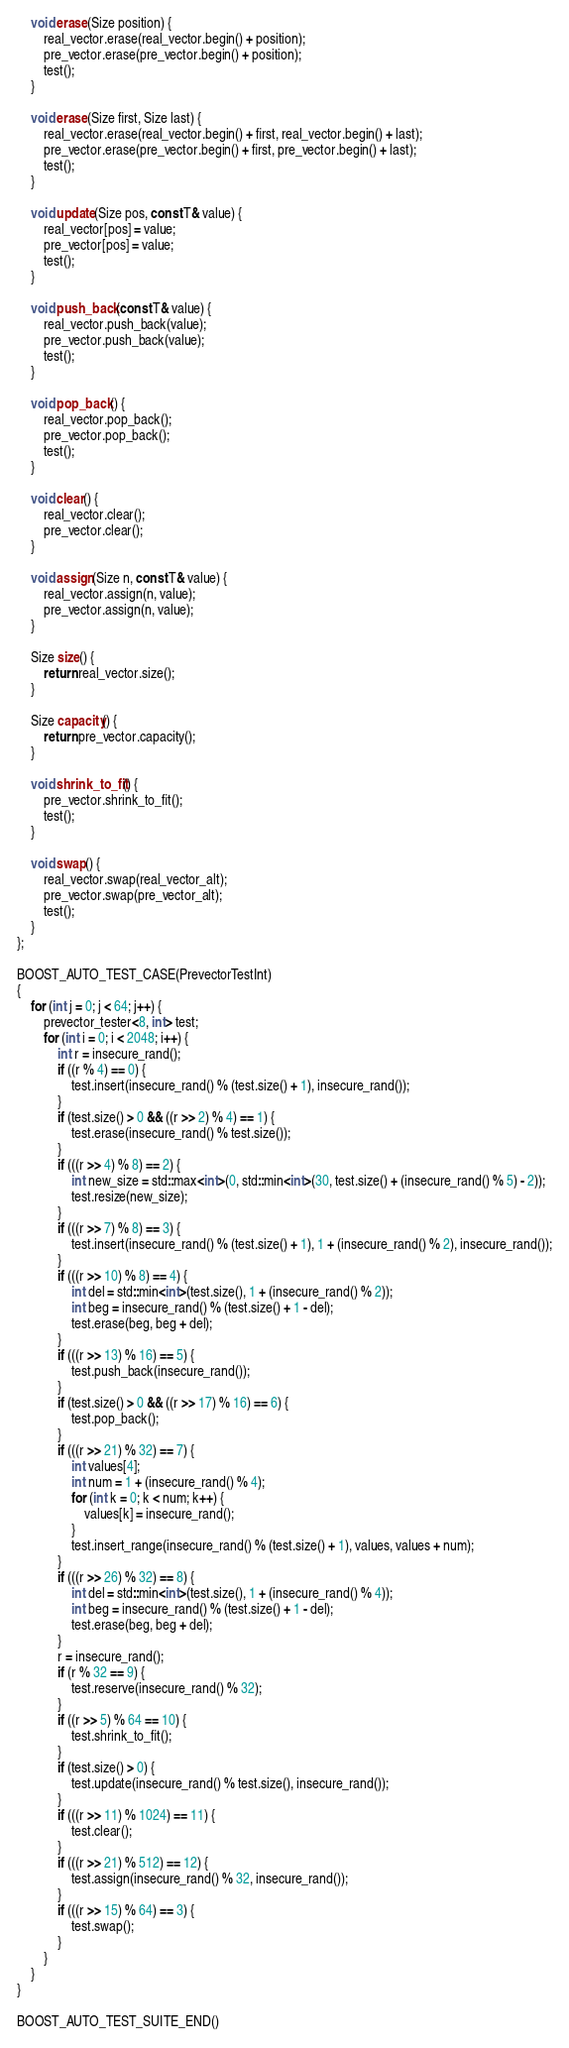<code> <loc_0><loc_0><loc_500><loc_500><_C++_>
    void erase(Size position) {
        real_vector.erase(real_vector.begin() + position);
        pre_vector.erase(pre_vector.begin() + position);
        test();
    }

    void erase(Size first, Size last) {
        real_vector.erase(real_vector.begin() + first, real_vector.begin() + last);
        pre_vector.erase(pre_vector.begin() + first, pre_vector.begin() + last);
        test();
    }

    void update(Size pos, const T& value) {
        real_vector[pos] = value;
        pre_vector[pos] = value;
        test();
    }

    void push_back(const T& value) {
        real_vector.push_back(value);
        pre_vector.push_back(value);
        test();
    }

    void pop_back() {
        real_vector.pop_back();
        pre_vector.pop_back();
        test();
    }

    void clear() {
        real_vector.clear();
        pre_vector.clear();
    }

    void assign(Size n, const T& value) {
        real_vector.assign(n, value);
        pre_vector.assign(n, value);
    }

    Size size() {
        return real_vector.size();
    }

    Size capacity() {
        return pre_vector.capacity();
    }

    void shrink_to_fit() {
        pre_vector.shrink_to_fit();
        test();
    }

    void swap() {
        real_vector.swap(real_vector_alt);
        pre_vector.swap(pre_vector_alt);
        test();
    }
};

BOOST_AUTO_TEST_CASE(PrevectorTestInt)
{
    for (int j = 0; j < 64; j++) {
        prevector_tester<8, int> test;
        for (int i = 0; i < 2048; i++) {
            int r = insecure_rand();
            if ((r % 4) == 0) {
                test.insert(insecure_rand() % (test.size() + 1), insecure_rand());
            }
            if (test.size() > 0 && ((r >> 2) % 4) == 1) {
                test.erase(insecure_rand() % test.size());
            }
            if (((r >> 4) % 8) == 2) {
                int new_size = std::max<int>(0, std::min<int>(30, test.size() + (insecure_rand() % 5) - 2));
                test.resize(new_size);
            }
            if (((r >> 7) % 8) == 3) {
                test.insert(insecure_rand() % (test.size() + 1), 1 + (insecure_rand() % 2), insecure_rand());
            }
            if (((r >> 10) % 8) == 4) {
                int del = std::min<int>(test.size(), 1 + (insecure_rand() % 2));
                int beg = insecure_rand() % (test.size() + 1 - del);
                test.erase(beg, beg + del);
            }
            if (((r >> 13) % 16) == 5) {
                test.push_back(insecure_rand());
            }
            if (test.size() > 0 && ((r >> 17) % 16) == 6) {
                test.pop_back();
            }
            if (((r >> 21) % 32) == 7) {
                int values[4];
                int num = 1 + (insecure_rand() % 4);
                for (int k = 0; k < num; k++) {
                    values[k] = insecure_rand();
                }
                test.insert_range(insecure_rand() % (test.size() + 1), values, values + num);
            }
            if (((r >> 26) % 32) == 8) {
                int del = std::min<int>(test.size(), 1 + (insecure_rand() % 4));
                int beg = insecure_rand() % (test.size() + 1 - del);
                test.erase(beg, beg + del);
            }
            r = insecure_rand();
            if (r % 32 == 9) {
                test.reserve(insecure_rand() % 32);
            }
            if ((r >> 5) % 64 == 10) {
                test.shrink_to_fit();
            }
            if (test.size() > 0) {
                test.update(insecure_rand() % test.size(), insecure_rand());
            }
            if (((r >> 11) % 1024) == 11) {
                test.clear();
            }
            if (((r >> 21) % 512) == 12) {
                test.assign(insecure_rand() % 32, insecure_rand());
            }
            if (((r >> 15) % 64) == 3) {
                test.swap();
            }
        }
    }
}

BOOST_AUTO_TEST_SUITE_END()
</code> 